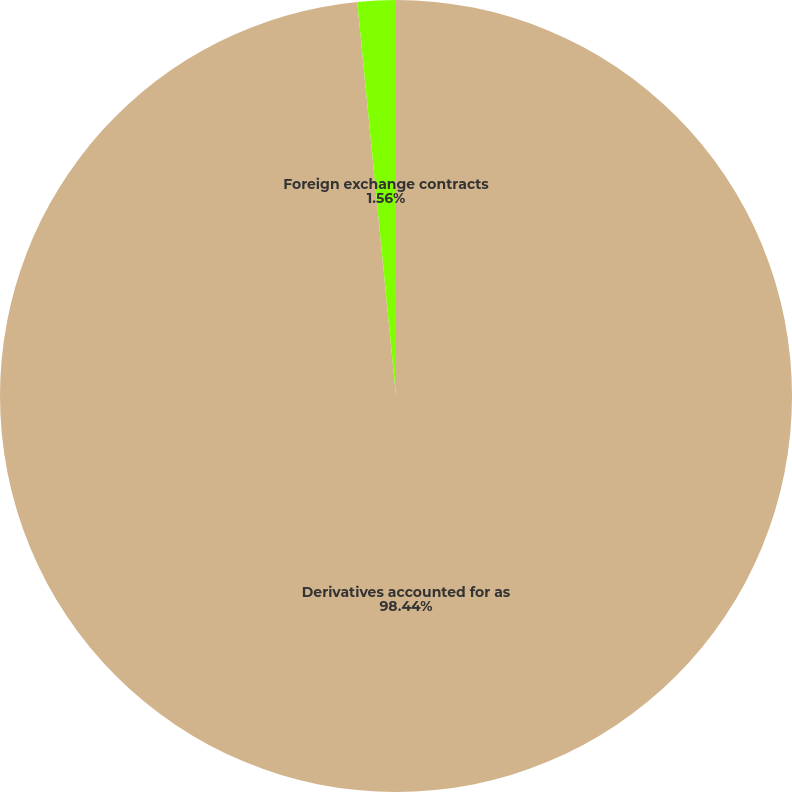Convert chart to OTSL. <chart><loc_0><loc_0><loc_500><loc_500><pie_chart><fcel>Derivatives accounted for as<fcel>Foreign exchange contracts<nl><fcel>98.44%<fcel>1.56%<nl></chart> 